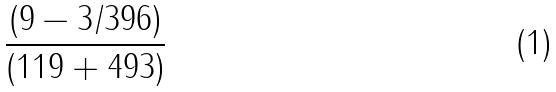<formula> <loc_0><loc_0><loc_500><loc_500>\frac { ( 9 - 3 / 3 9 6 ) } { ( 1 1 9 + 4 9 3 ) }</formula> 